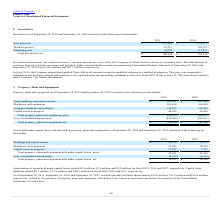From Plexus's financial document, Which years does the table provide information for inventories? The document shows two values: 2019 and 2018. From the document: "Inventories as of September 28, 2019 and September 29, 2018 consisted of the following (in thousands): tories as of September 28, 2019 and September 2..." Also, What was the amount of Work-in-process in 2018? According to the financial document, 102,337 (in thousands). The relevant text states: "Work-in-process 49,315 102,337..." Also, What was the amount of customer deposits related to inventory and included within current liabilities on the accompanying Consolidated Balance Sheets in 2019? According to the financial document, 136.5 (in millions). The relevant text states: "of September 28, 2019 and September 29, 2018 was $136.5 million and $87.7 million, respectively...." Also, How many years did net total inventories exceed $700,000 thousand? Counting the relevant items in the document: 2019, 2018, I find 2 instances. The key data points involved are: 2018, 2019. Also, can you calculate: What was the change in the amount of Finished goods between 2018 and 2019? Based on the calculation: 74,078-112,632, the result is -38554 (in thousands). This is based on the information: "Finished goods 74,078 112,632 Finished goods 74,078 112,632..." The key data points involved are: 112,632, 74,078. Also, can you calculate: What was the percentage change in the work-in-process between 2018 and 2019? To answer this question, I need to perform calculations using the financial data. The calculation is: (49,315-102,337)/102,337, which equals -51.81 (percentage). This is based on the information: "Work-in-process 49,315 102,337 Work-in-process 49,315 102,337..." The key data points involved are: 102,337, 49,315. 